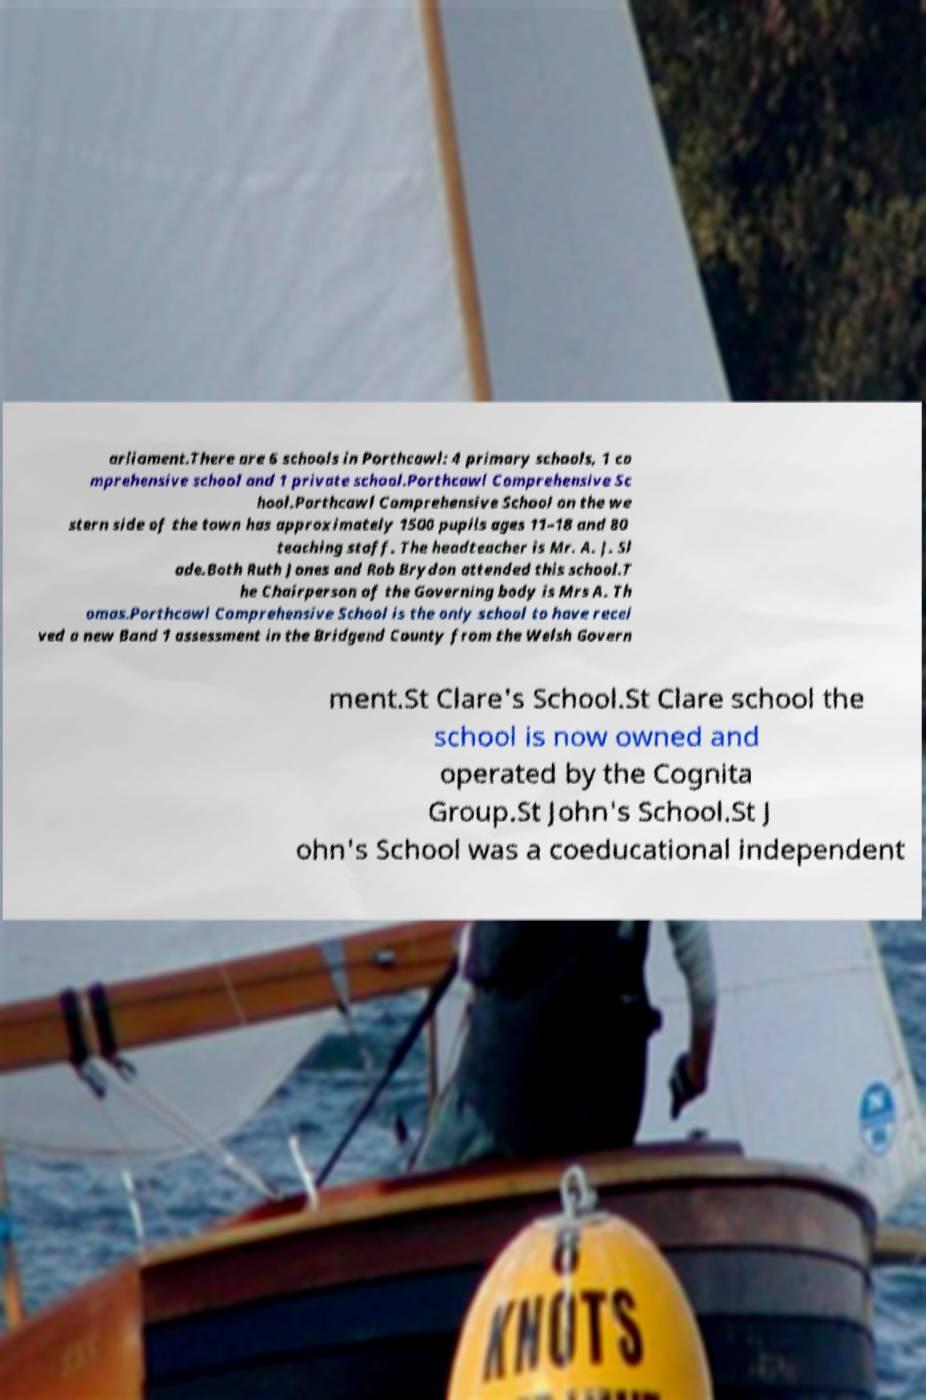I need the written content from this picture converted into text. Can you do that? arliament.There are 6 schools in Porthcawl: 4 primary schools, 1 co mprehensive school and 1 private school.Porthcawl Comprehensive Sc hool.Porthcawl Comprehensive School on the we stern side of the town has approximately 1500 pupils ages 11–18 and 80 teaching staff. The headteacher is Mr. A. J. Sl ade.Both Ruth Jones and Rob Brydon attended this school.T he Chairperson of the Governing body is Mrs A. Th omas.Porthcawl Comprehensive School is the only school to have recei ved a new Band 1 assessment in the Bridgend County from the Welsh Govern ment.St Clare's School.St Clare school the school is now owned and operated by the Cognita Group.St John's School.St J ohn's School was a coeducational independent 